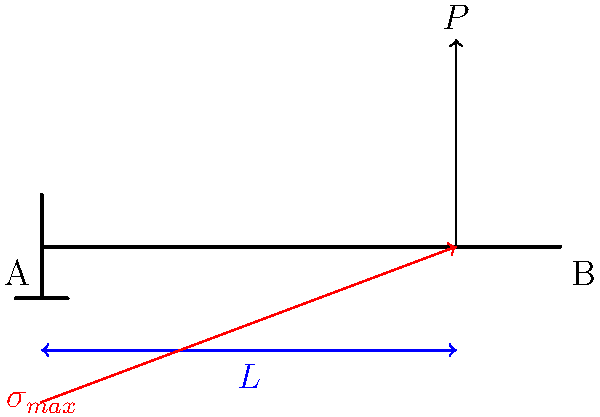As a supportive partner researching natural remedies, you've stumbled upon an interesting mechanical engineering concept. In a cantilever beam under a point load $P$ at its free end, what is the relationship between the maximum stress $\sigma_{max}$ at the fixed end (point A) and the stress at the point of load application (point B)? Let's approach this step-by-step:

1) In a cantilever beam, the maximum bending stress occurs at the fixed end (point A) and decreases linearly to zero at the free end.

2) The bending moment $M$ at any point $x$ along the beam is given by:
   $M = P(L-x)$, where $L$ is the length of the beam.

3) The bending stress $\sigma$ at any point is given by:
   $\sigma = \frac{My}{I}$, where $y$ is the distance from the neutral axis and $I$ is the moment of inertia.

4) At the fixed end (x = 0), the maximum stress is:
   $\sigma_{max} = \frac{PL\cdot y_{max}}{I}$

5) At the point of load application (x = L), the stress is zero.

6) The stress distribution is linear, so at the point of load application (point B), which is at the same $y$ distance from the neutral axis as point A, the stress would be zero.

7) Therefore, the relationship between the stress at point A ($\sigma_{max}$) and point B (which is zero) is that point A experiences the maximum stress while point B experiences no bending stress.

This stress distribution is similar to how natural remedies often work gradually in the body, with the highest concentration at the point of application and diminishing effects further away.
Answer: $\sigma_A = \sigma_{max}$, $\sigma_B = 0$ 